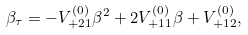<formula> <loc_0><loc_0><loc_500><loc_500>\beta _ { \tau } = - V _ { + 2 1 } ^ { ( 0 ) } \beta ^ { 2 } + 2 V ^ { ( 0 ) } _ { + 1 1 } \beta + V ^ { ( 0 ) } _ { + 1 2 } ,</formula> 